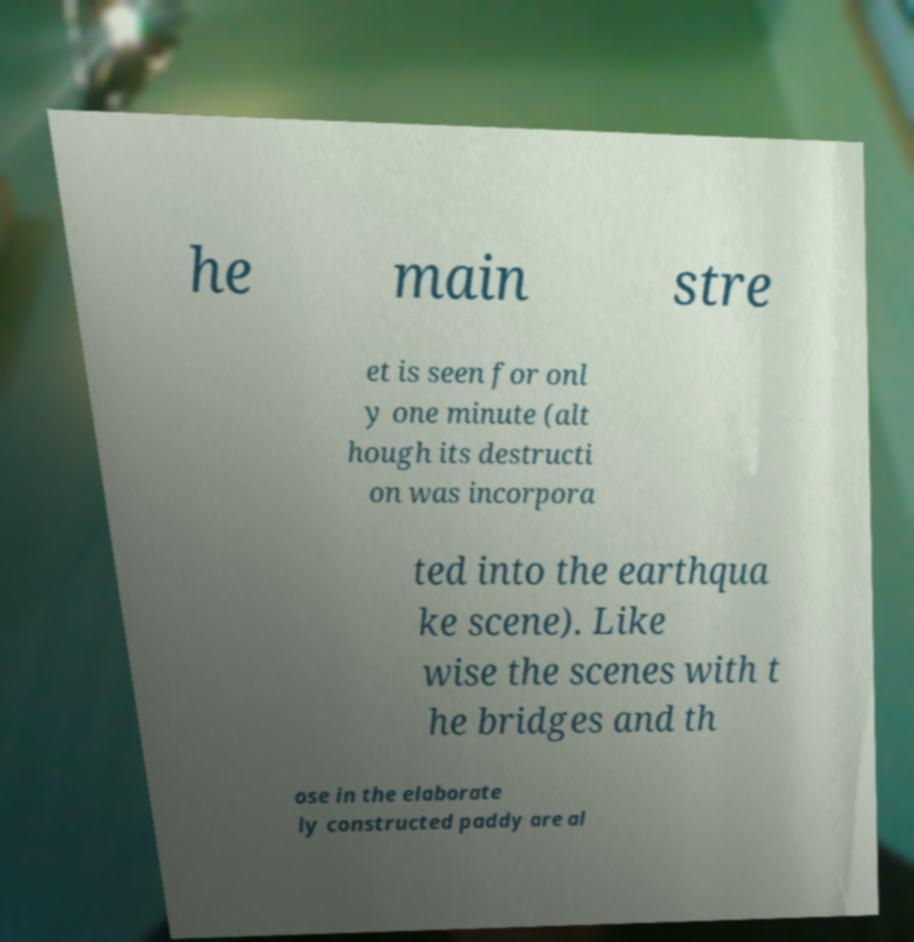I need the written content from this picture converted into text. Can you do that? he main stre et is seen for onl y one minute (alt hough its destructi on was incorpora ted into the earthqua ke scene). Like wise the scenes with t he bridges and th ose in the elaborate ly constructed paddy are al 